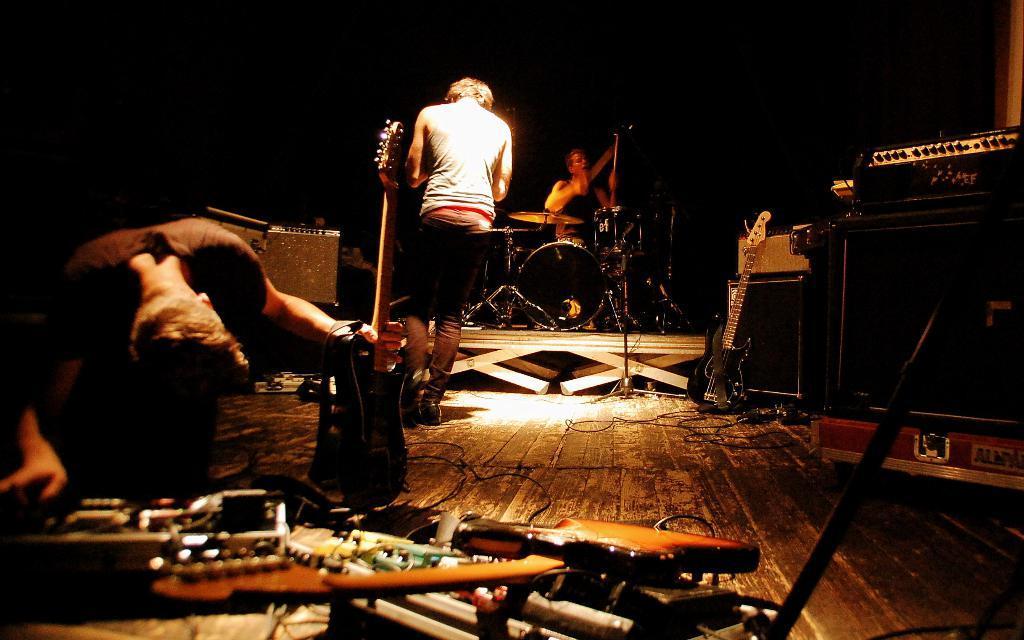In one or two sentences, can you explain what this image depicts? Three men are performing on a stage. Of them a man is holding a guitar and other is playing drums. 